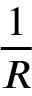<formula> <loc_0><loc_0><loc_500><loc_500>\frac { 1 } { R }</formula> 